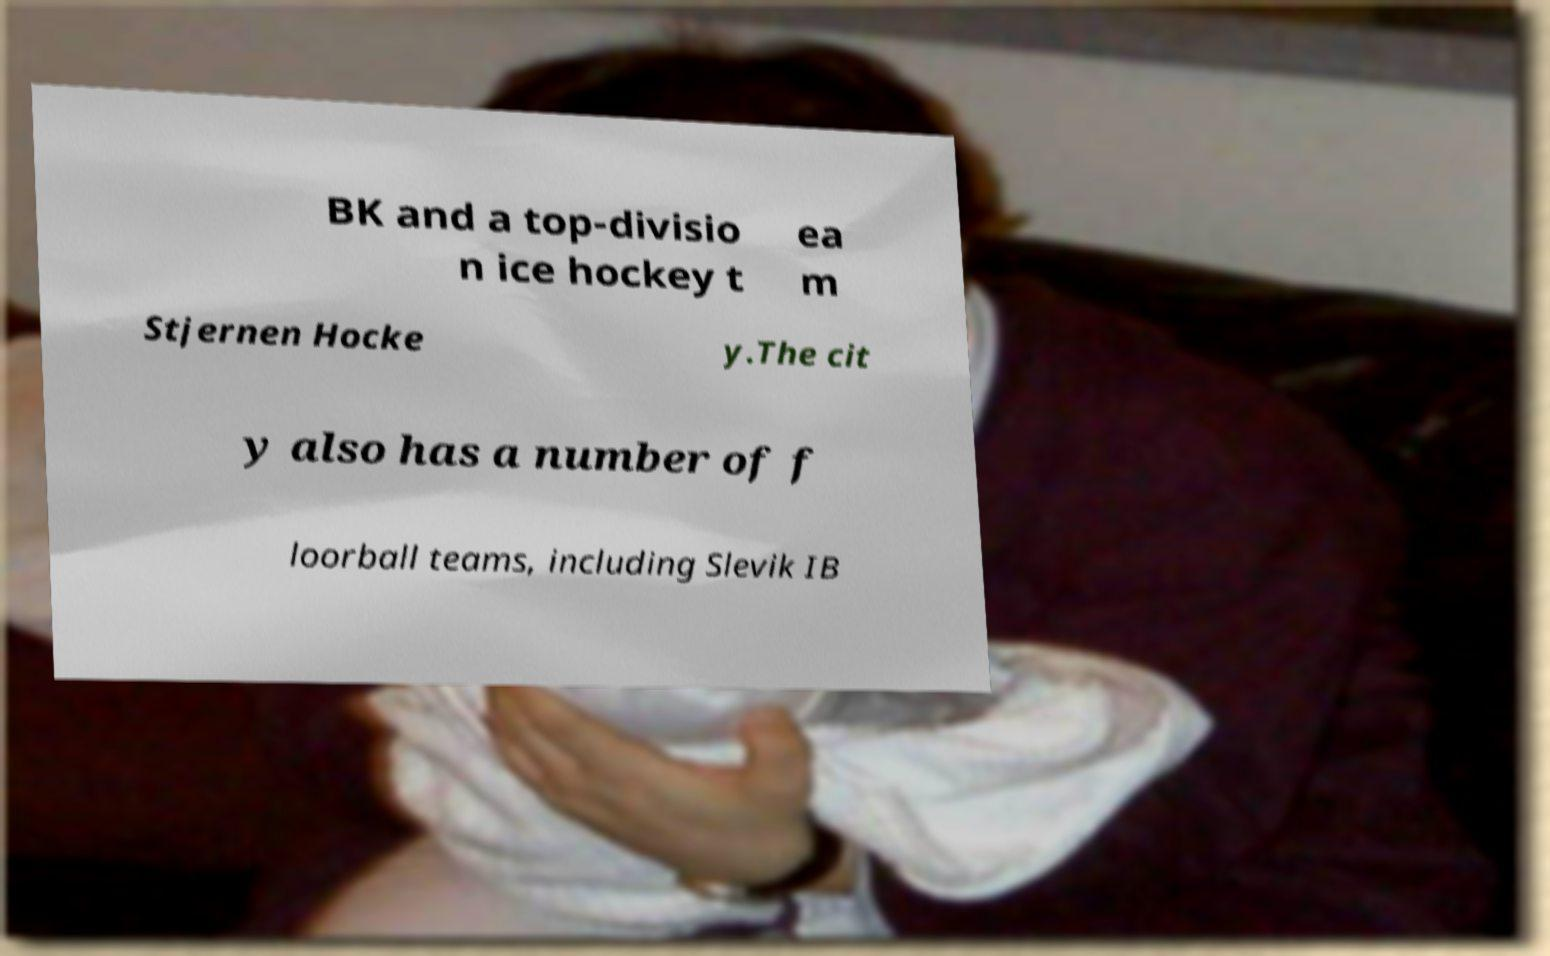Can you read and provide the text displayed in the image?This photo seems to have some interesting text. Can you extract and type it out for me? BK and a top-divisio n ice hockey t ea m Stjernen Hocke y.The cit y also has a number of f loorball teams, including Slevik IB 